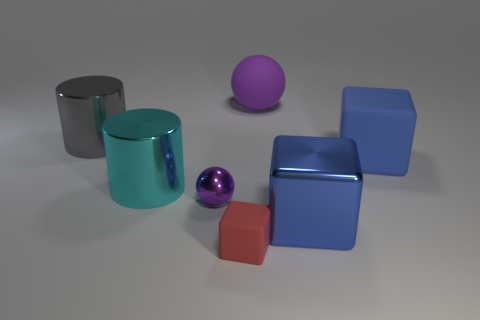Add 2 gray rubber cylinders. How many objects exist? 9 Subtract all big metal cubes. How many cubes are left? 2 Subtract all spheres. How many objects are left? 5 Subtract 1 cylinders. How many cylinders are left? 1 Subtract all gray shiny things. Subtract all tiny purple metal things. How many objects are left? 5 Add 4 big things. How many big things are left? 9 Add 1 large rubber things. How many large rubber things exist? 3 Subtract all blue blocks. How many blocks are left? 1 Subtract 0 cyan spheres. How many objects are left? 7 Subtract all purple blocks. Subtract all yellow spheres. How many blocks are left? 3 